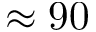<formula> <loc_0><loc_0><loc_500><loc_500>\approx 9 0</formula> 